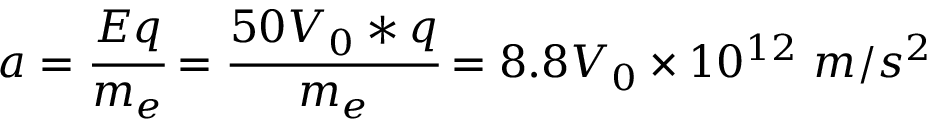<formula> <loc_0><loc_0><loc_500><loc_500>a = \cfrac { E q } { m _ { e } } = \cfrac { 5 0 V _ { 0 } * q } { m _ { e } } = 8 . 8 V _ { 0 } \times 1 0 ^ { 1 2 } m / s ^ { 2 }</formula> 